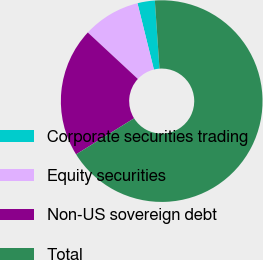Convert chart to OTSL. <chart><loc_0><loc_0><loc_500><loc_500><pie_chart><fcel>Corporate securities trading<fcel>Equity securities<fcel>Non-US sovereign debt<fcel>Total<nl><fcel>2.78%<fcel>9.23%<fcel>20.77%<fcel>67.22%<nl></chart> 